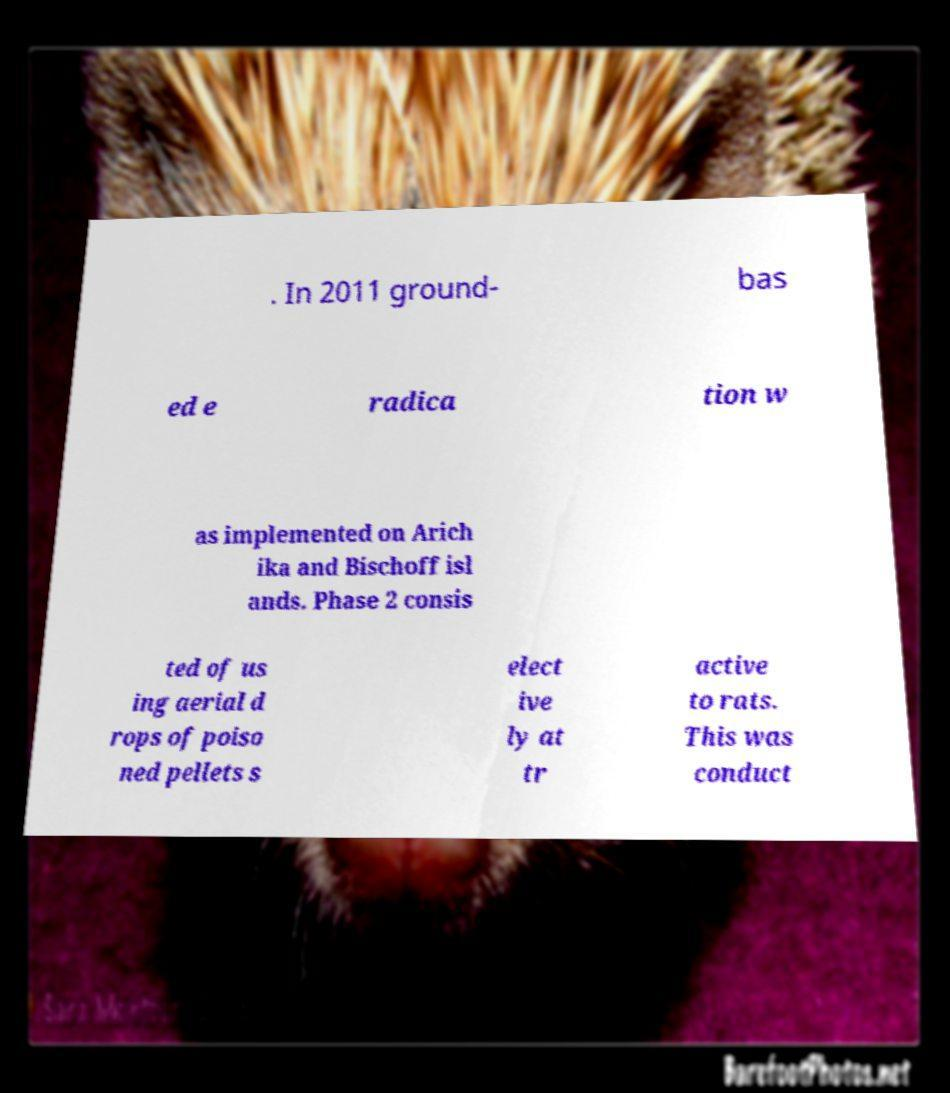I need the written content from this picture converted into text. Can you do that? . In 2011 ground- bas ed e radica tion w as implemented on Arich ika and Bischoff isl ands. Phase 2 consis ted of us ing aerial d rops of poiso ned pellets s elect ive ly at tr active to rats. This was conduct 